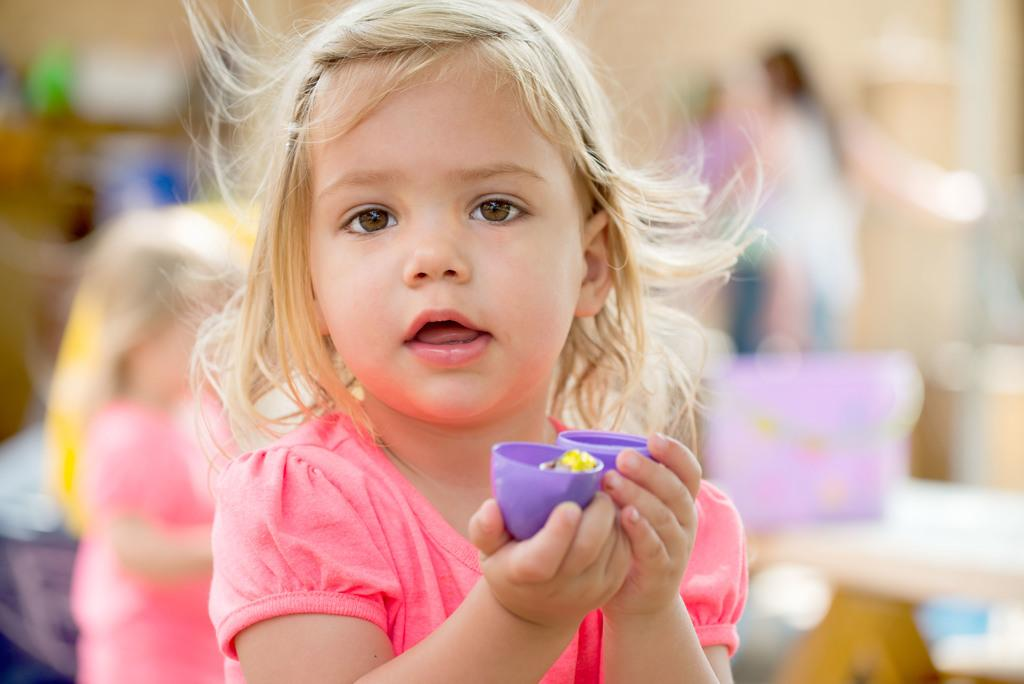What is the main subject of the image? The main subject of the image is a kid. What is the kid doing in the image? The kid is holding some objects. Can you describe the background of the image? The background of the image is blurred. What type of plastic iron can be seen in the image? There is no plastic iron present in the image. 